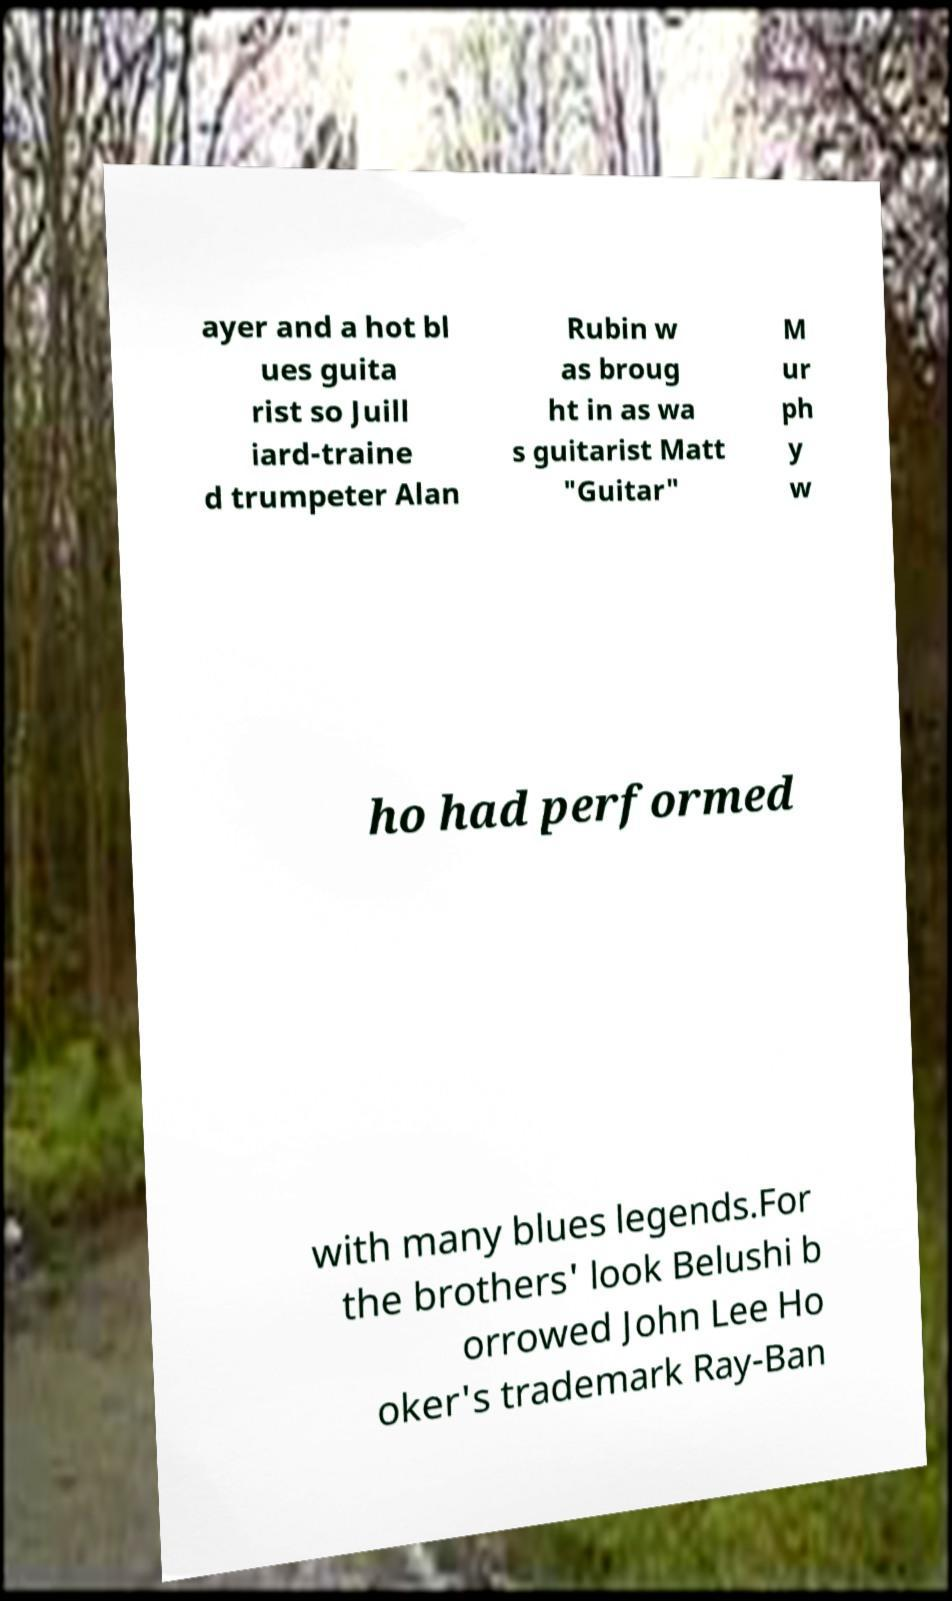What messages or text are displayed in this image? I need them in a readable, typed format. ayer and a hot bl ues guita rist so Juill iard-traine d trumpeter Alan Rubin w as broug ht in as wa s guitarist Matt "Guitar" M ur ph y w ho had performed with many blues legends.For the brothers' look Belushi b orrowed John Lee Ho oker's trademark Ray-Ban 